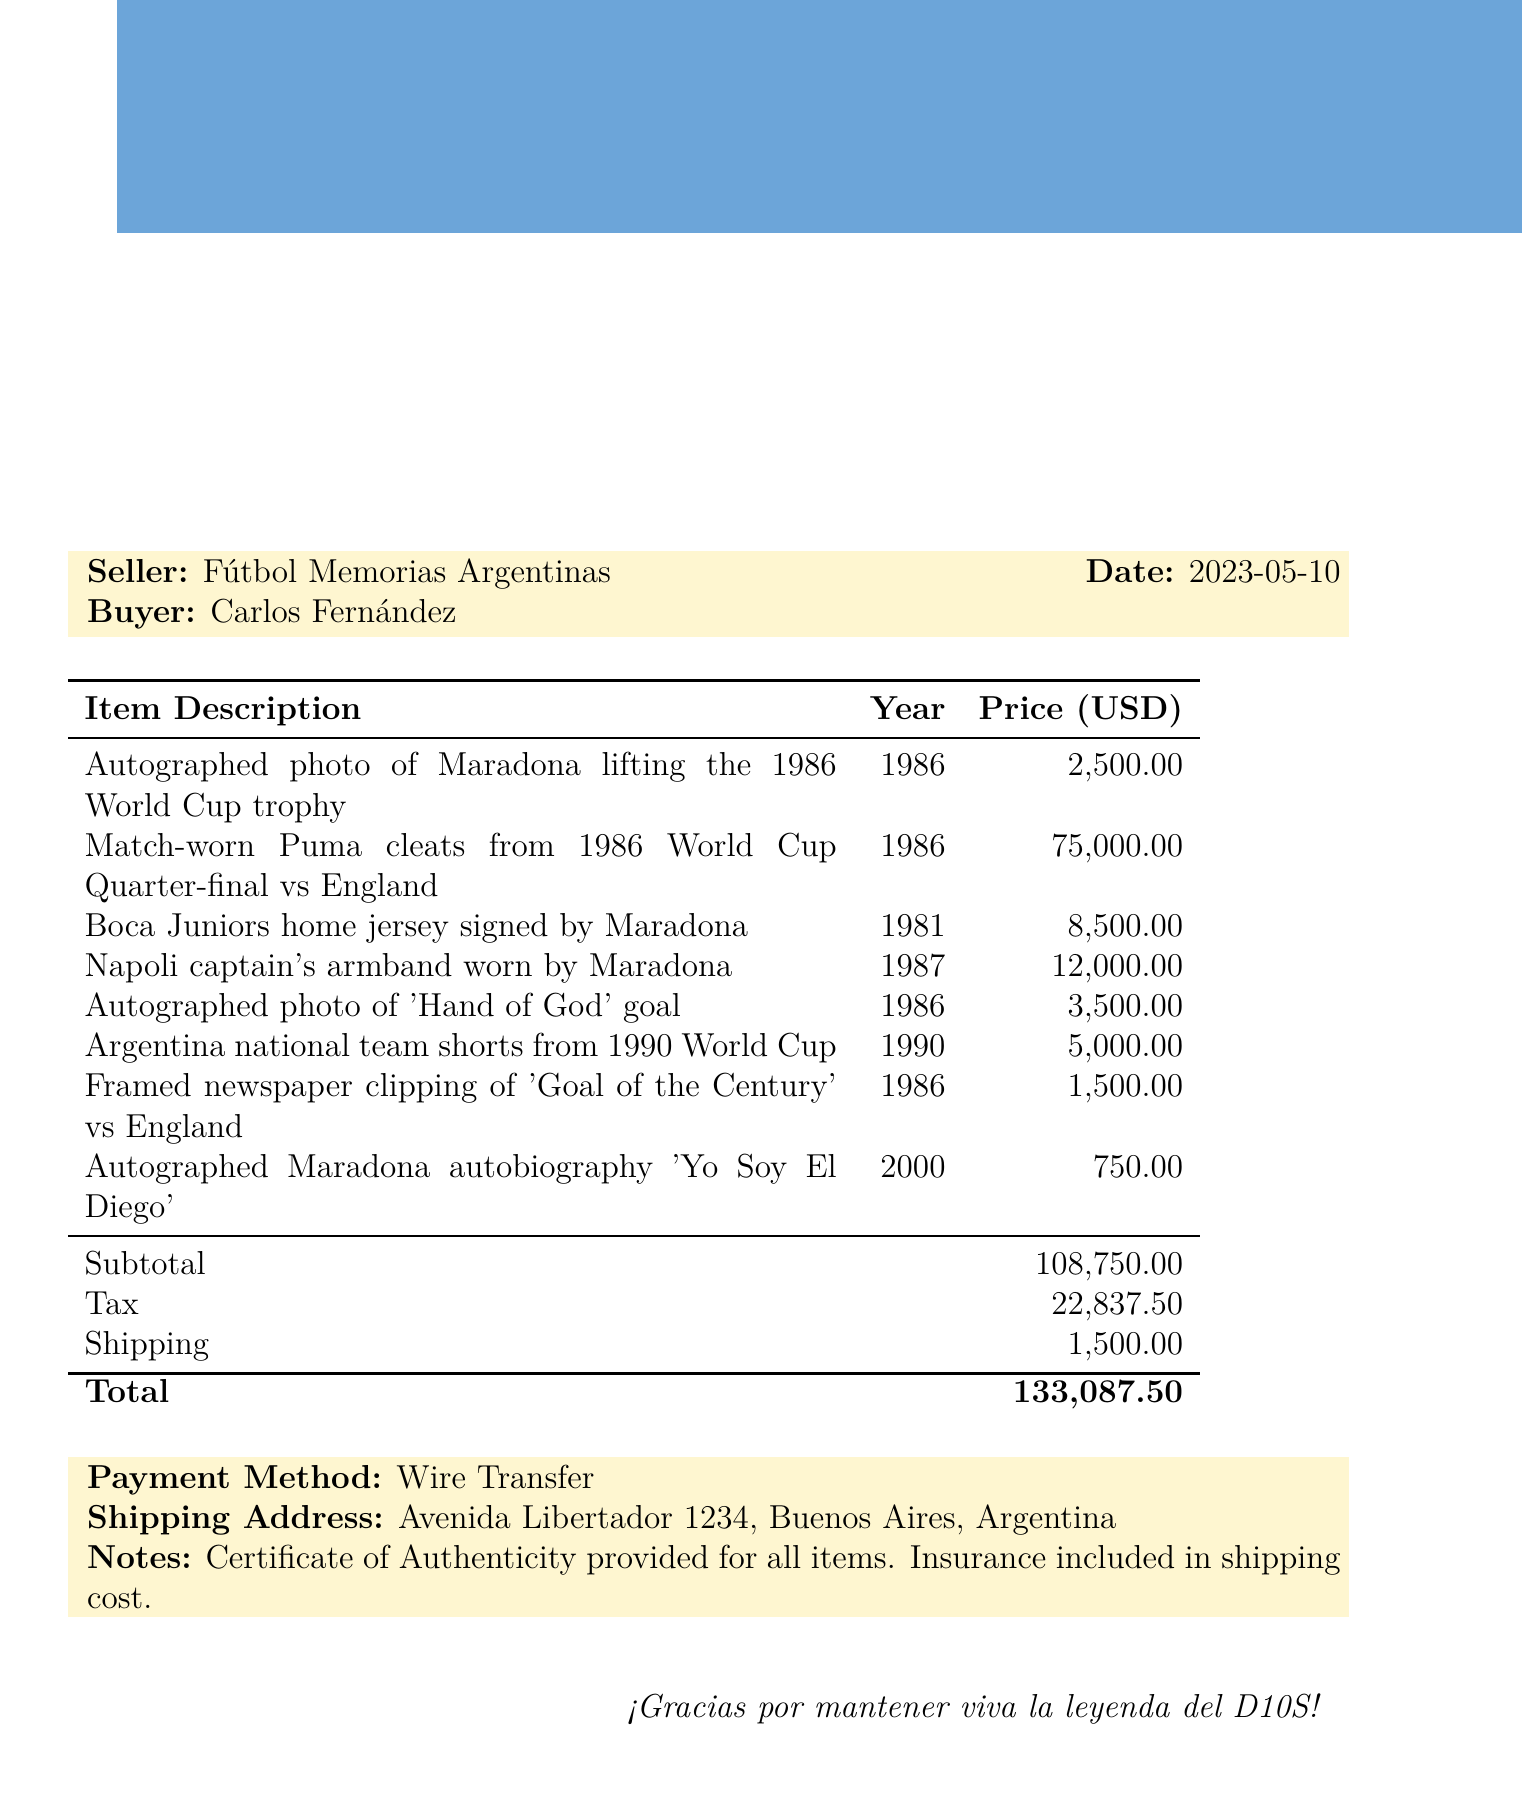What is the seller's name? The seller's name is stated at the beginning of the document for easy identification.
Answer: Fútbol Memorias Argentinas What is the total amount due? The total amount is the final figure provided at the end of the document, after summing the subtotal, tax, and shipping.
Answer: 133,087.50 How many items are listed in the document? The number of items is determined by counting each individual entry in the itemized list.
Answer: 8 What is the price of the match-worn Puma cleats? The price for this specific item is clearly indicated next to its description in the table.
Answer: 75,000 What was the year of the autographed photo of Maradona lifting the World Cup trophy? The year is specified in the item description table for clarity on the item's historical context.
Answer: 1986 What is the shipping method mentioned in the document? The payment method is indicated in the notes section, specifying how the buyer intends to pay.
Answer: Wire Transfer Which item has a condition rated as "Like New"? The condition of items is stated alongside their descriptions, making it easy to identify this specific one.
Answer: Autographed Maradona autobiography 'Yo Soy El Diego' Where is the shipping address located? The complete shipping address is provided in the document, with all necessary details for delivery.
Answer: Avenida Libertador 1234, Buenos Aires, Argentina What certificate is mentioned in the notes? The notes section includes details about any certificates related to the items being sold, which is pertinent for authenticity.
Answer: Certificate of Authenticity 